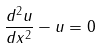<formula> <loc_0><loc_0><loc_500><loc_500>\frac { d ^ { 2 } u } { d x ^ { 2 } } - u = 0</formula> 